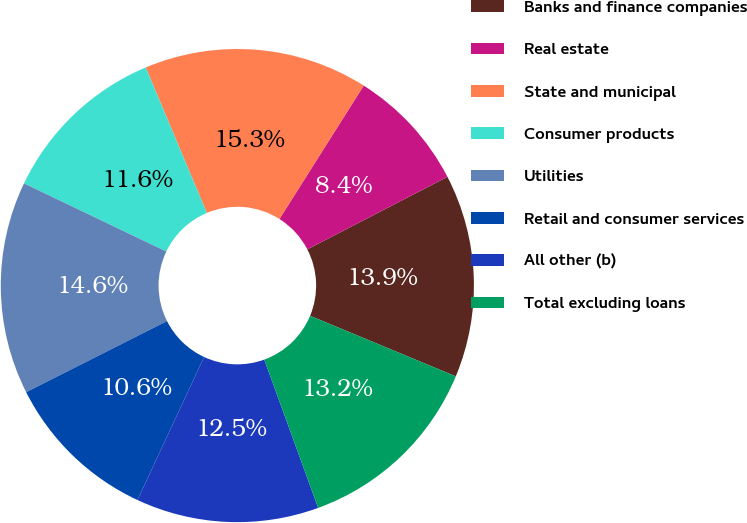Convert chart. <chart><loc_0><loc_0><loc_500><loc_500><pie_chart><fcel>Banks and finance companies<fcel>Real estate<fcel>State and municipal<fcel>Consumer products<fcel>Utilities<fcel>Retail and consumer services<fcel>All other (b)<fcel>Total excluding loans<nl><fcel>13.87%<fcel>8.43%<fcel>15.3%<fcel>11.56%<fcel>14.55%<fcel>10.62%<fcel>12.49%<fcel>13.18%<nl></chart> 